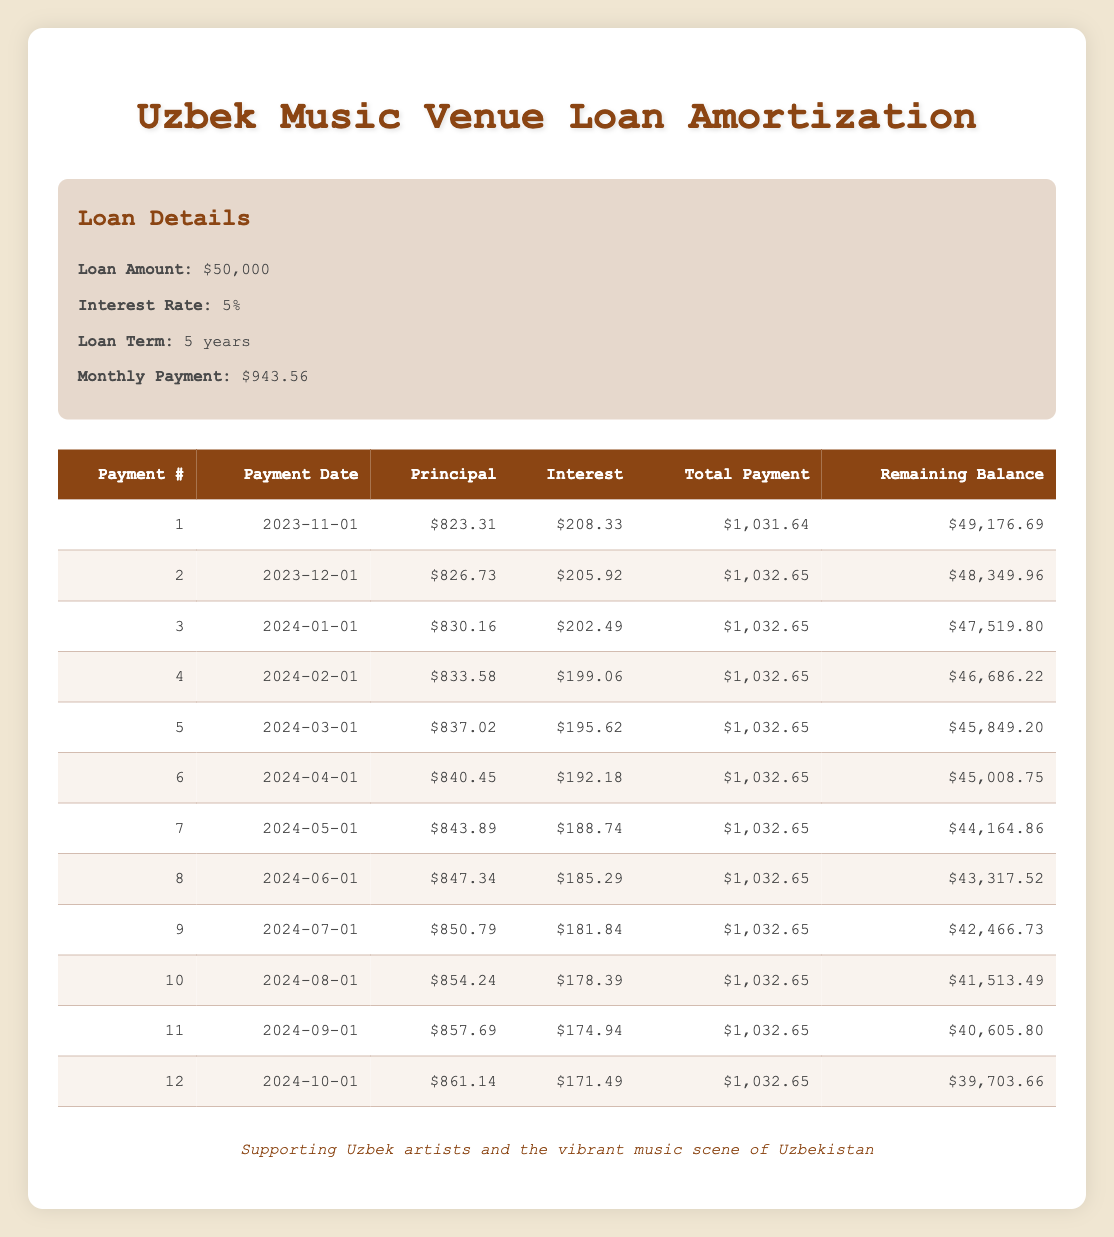What's the total amount of the loan? The loan amount is clearly stated in the loan details section of the table. It indicates that the total amount of the loan is $50,000.
Answer: 50000 What is the interest rate of the loan? The interest rate is provided in the loan details section of the table, which specifies it as 5%.
Answer: 5% What is the total payment for the first month? Referring to the first row of the repayment schedule, the total payment amount listed is $1,031.64 for the first payment.
Answer: 1031.64 How much principal is paid off in the third payment? From the third row of the repayment schedule, the principal payment amount shown is $830.16 for the third payment.
Answer: 830.16 What is the remaining balance after the sixth payment? Looking at the sixth row in the repayment schedule, the remaining balance is shown as $45,008.75 after the sixth payment.
Answer: 45008.75 What is the average monthly principal payment over the first 12 months? To calculate the average monthly principal payment, sum the principal payments for the first 12 months: (823.31 + 826.73 + 830.16 + 833.58 + 837.02 + 840.45 + 843.89 + 847.34 + 850.79 + 854.24 + 857.69 + 861.14) = 10263.94, and then divide this sum by 12 which equals 855.33.
Answer: 855.33 Is the interest payment decreasing with each payment? If we examine the interest payments in the table, they show a decreasing trend from 208.33 in the first payment to 171.49 in the twelfth payment. This indicates that the interest payment decreases over time as the principal balance reduces.
Answer: Yes How much total payment will be made by the end of the loan term? The total amount paid over the loan term is calculated by multiplying the monthly payment amount by the number of payments: $943.56 * 60 months = $56,613.60.
Answer: 56613.60 After how many payments will the remaining balance fall below $40,000? By observing the remaining balances column, the value falls below $40,000 after the 11th payment (40,605.80), as the balance will be $39,703.66 after the 12th payment. Therefore, it is after 12 payments.
Answer: 12 